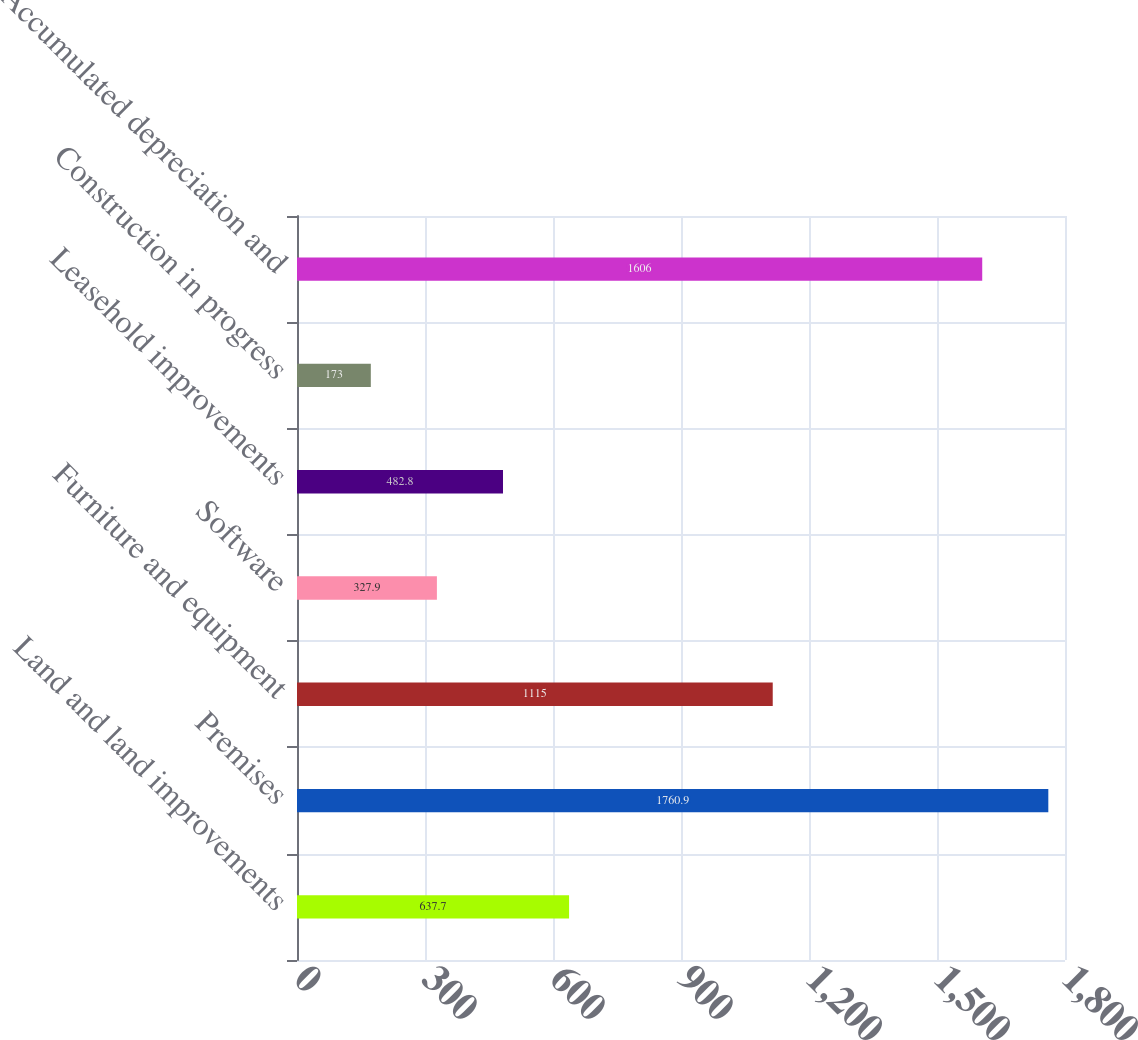Convert chart. <chart><loc_0><loc_0><loc_500><loc_500><bar_chart><fcel>Land and land improvements<fcel>Premises<fcel>Furniture and equipment<fcel>Software<fcel>Leasehold improvements<fcel>Construction in progress<fcel>Accumulated depreciation and<nl><fcel>637.7<fcel>1760.9<fcel>1115<fcel>327.9<fcel>482.8<fcel>173<fcel>1606<nl></chart> 